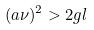<formula> <loc_0><loc_0><loc_500><loc_500>( a \nu ) ^ { 2 } > 2 g l</formula> 